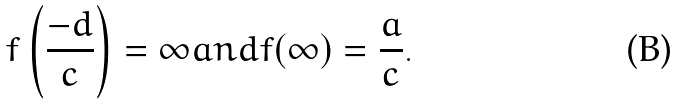Convert formula to latex. <formula><loc_0><loc_0><loc_500><loc_500>f \left ( { \frac { - d } { c } } \right ) = \infty { a n d } f ( \infty ) = { \frac { a } { c } } .</formula> 